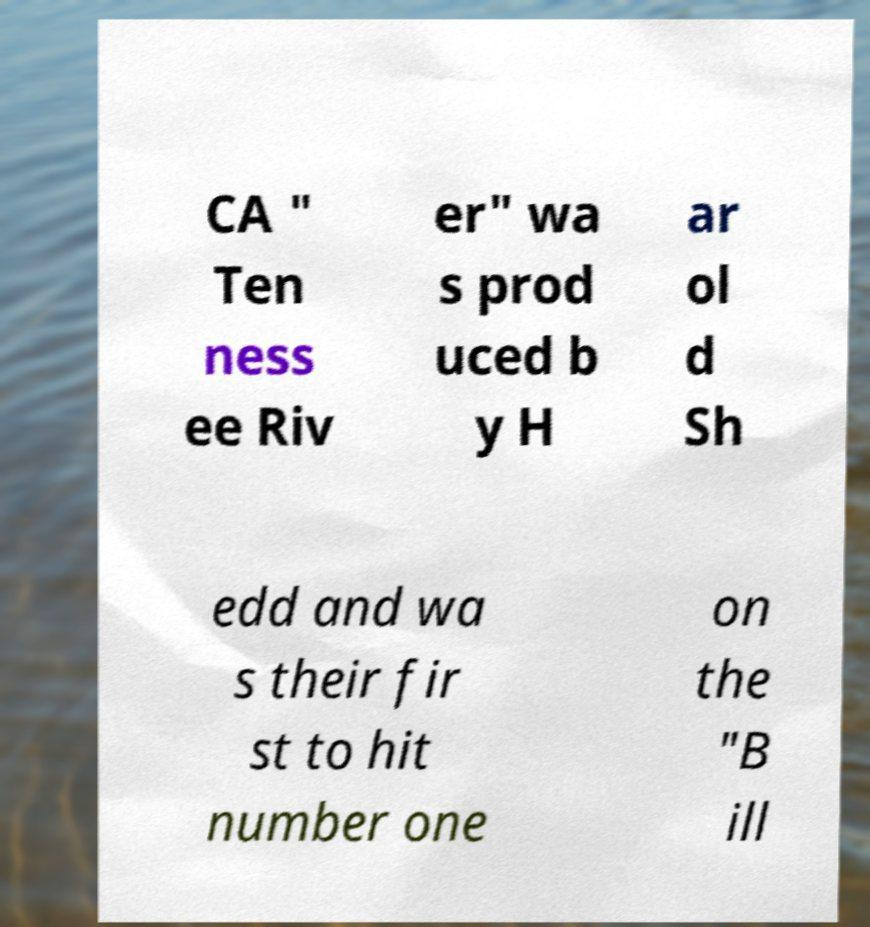There's text embedded in this image that I need extracted. Can you transcribe it verbatim? CA " Ten ness ee Riv er" wa s prod uced b y H ar ol d Sh edd and wa s their fir st to hit number one on the "B ill 